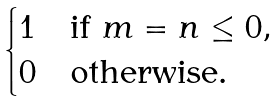Convert formula to latex. <formula><loc_0><loc_0><loc_500><loc_500>\begin{cases} 1 & \text {if $m = n \leq 0$} , \\ 0 & \text {otherwise} . \end{cases}</formula> 